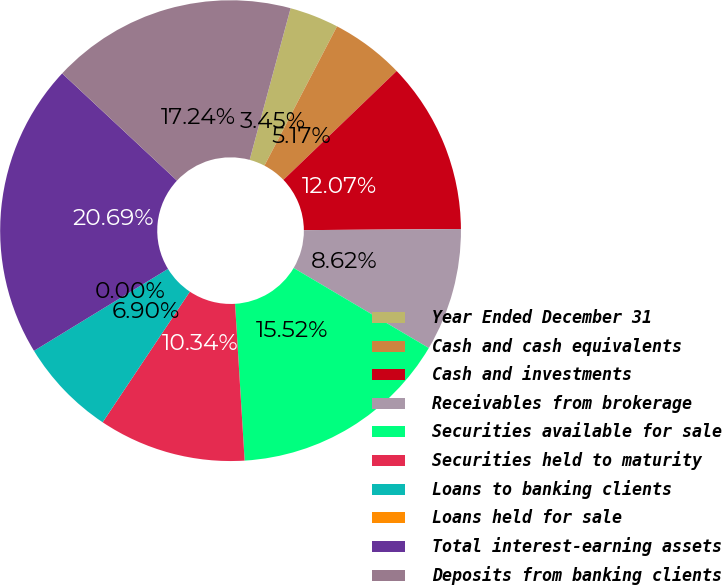Convert chart to OTSL. <chart><loc_0><loc_0><loc_500><loc_500><pie_chart><fcel>Year Ended December 31<fcel>Cash and cash equivalents<fcel>Cash and investments<fcel>Receivables from brokerage<fcel>Securities available for sale<fcel>Securities held to maturity<fcel>Loans to banking clients<fcel>Loans held for sale<fcel>Total interest-earning assets<fcel>Deposits from banking clients<nl><fcel>3.45%<fcel>5.17%<fcel>12.07%<fcel>8.62%<fcel>15.52%<fcel>10.34%<fcel>6.9%<fcel>0.0%<fcel>20.69%<fcel>17.24%<nl></chart> 